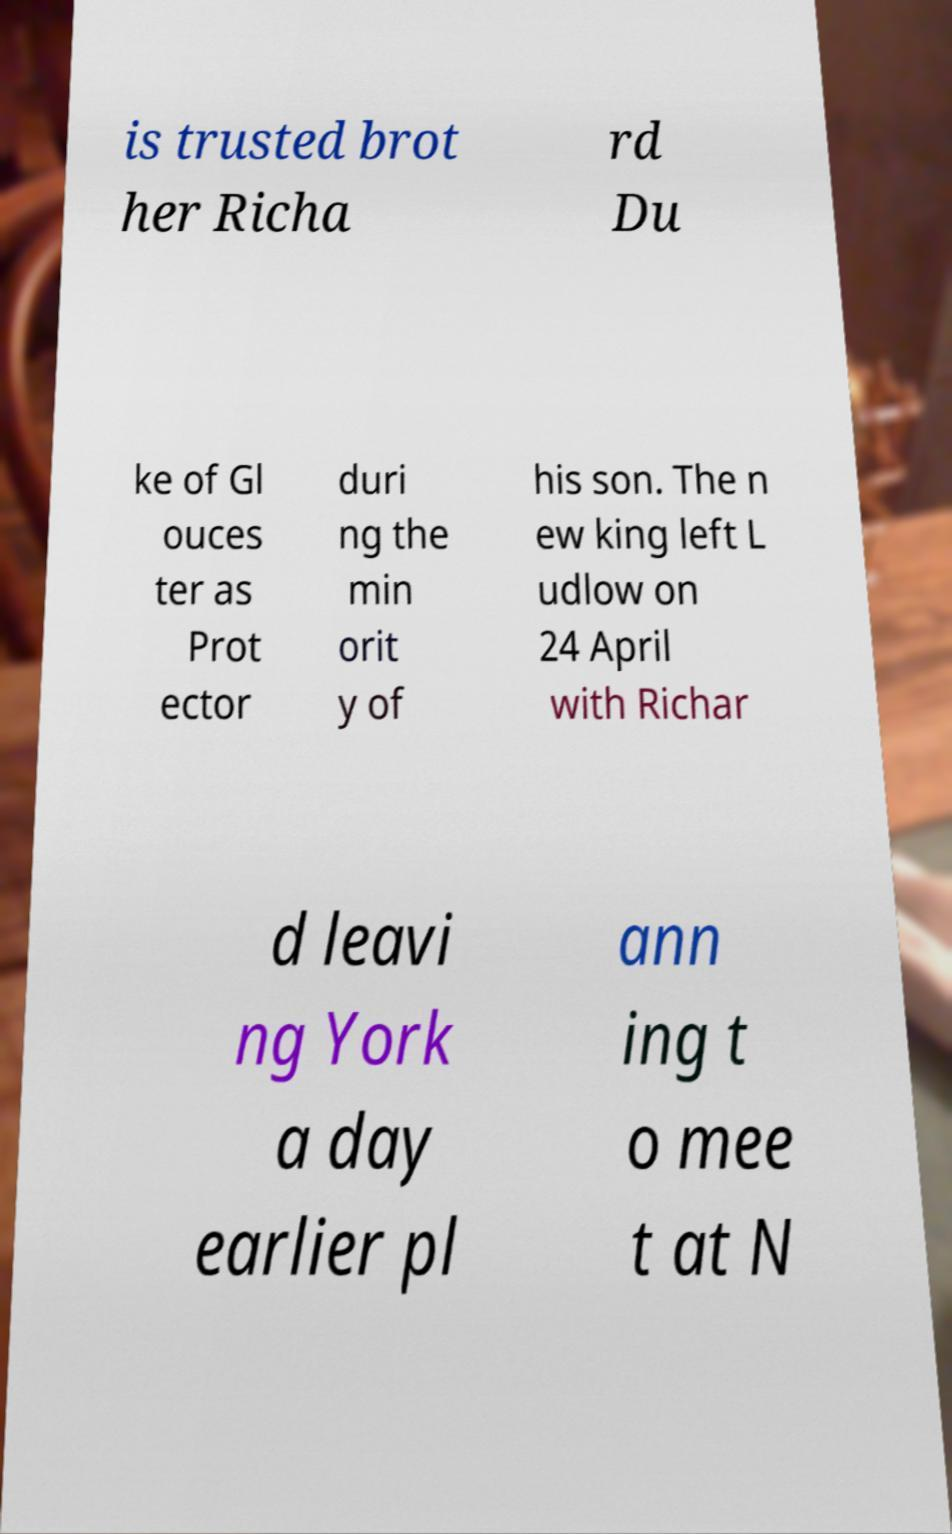Can you read and provide the text displayed in the image?This photo seems to have some interesting text. Can you extract and type it out for me? is trusted brot her Richa rd Du ke of Gl ouces ter as Prot ector duri ng the min orit y of his son. The n ew king left L udlow on 24 April with Richar d leavi ng York a day earlier pl ann ing t o mee t at N 